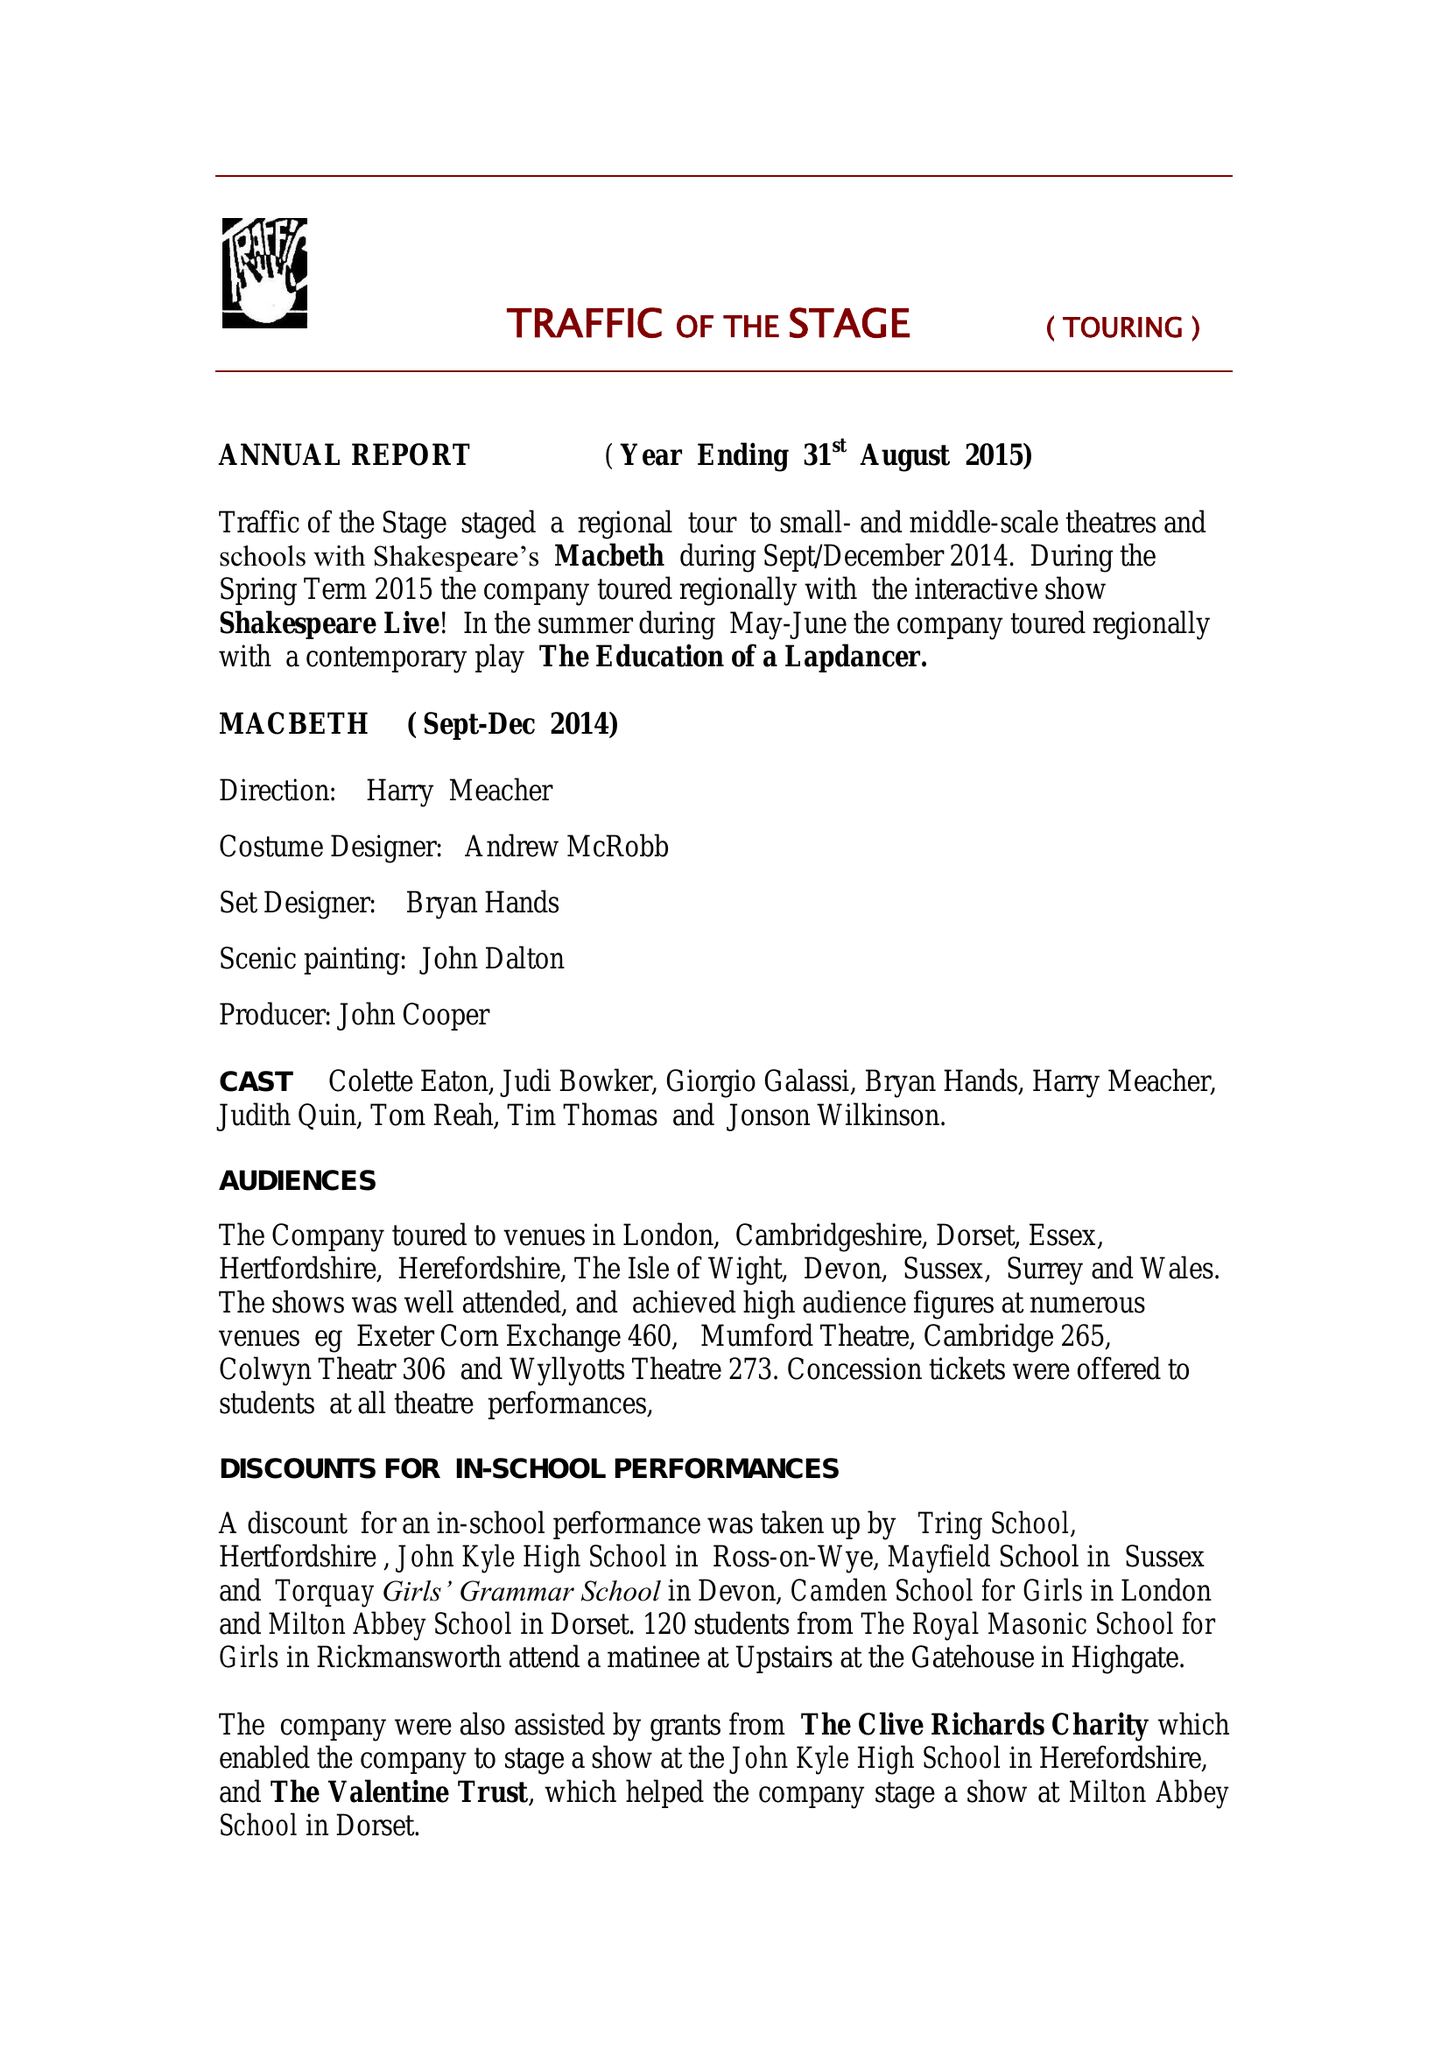What is the value for the charity_name?
Answer the question using a single word or phrase. Traffic Of The Stage Touring 